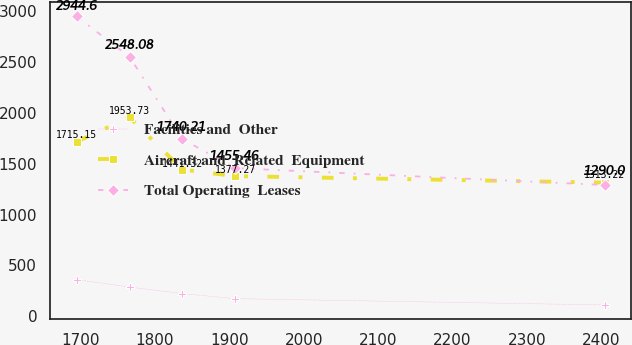Convert chart. <chart><loc_0><loc_0><loc_500><loc_500><line_chart><ecel><fcel>Facilities and  Other<fcel>Aircraft and  Related  Equipment<fcel>Total Operating  Leases<nl><fcel>1694.86<fcel>361.28<fcel>1715.15<fcel>2944.6<nl><fcel>1765.88<fcel>287.8<fcel>1953.73<fcel>2548.08<nl><fcel>1836.91<fcel>223.97<fcel>1441.32<fcel>1740.21<nl><fcel>1907.94<fcel>173.86<fcel>1377.27<fcel>1455.46<nl><fcel>2405.11<fcel>112.2<fcel>1313.22<fcel>1290<nl></chart> 